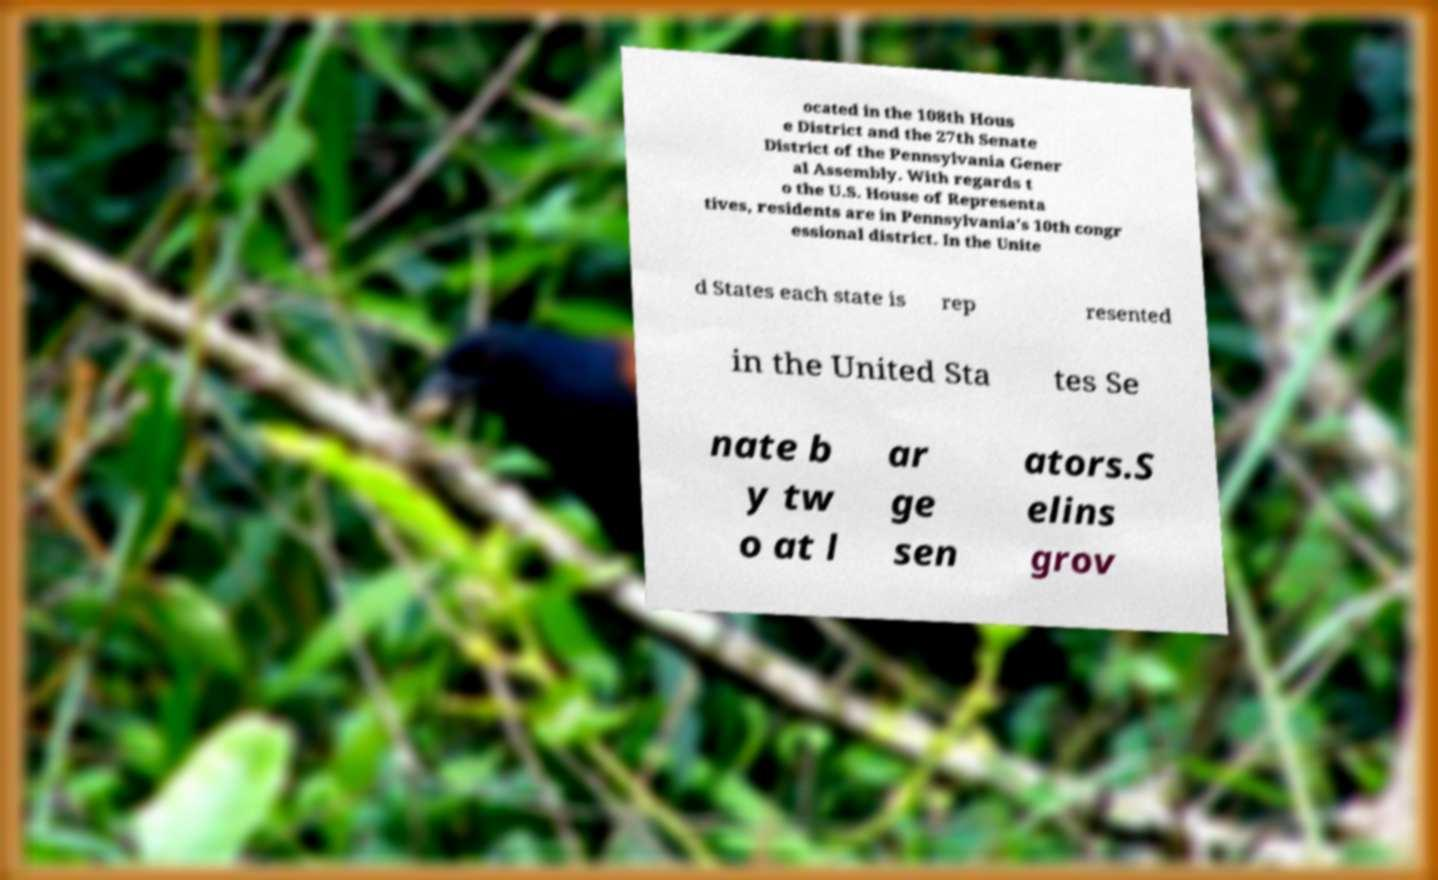Please identify and transcribe the text found in this image. ocated in the 108th Hous e District and the 27th Senate District of the Pennsylvania Gener al Assembly. With regards t o the U.S. House of Representa tives, residents are in Pennsylvania's 10th congr essional district. In the Unite d States each state is rep resented in the United Sta tes Se nate b y tw o at l ar ge sen ators.S elins grov 